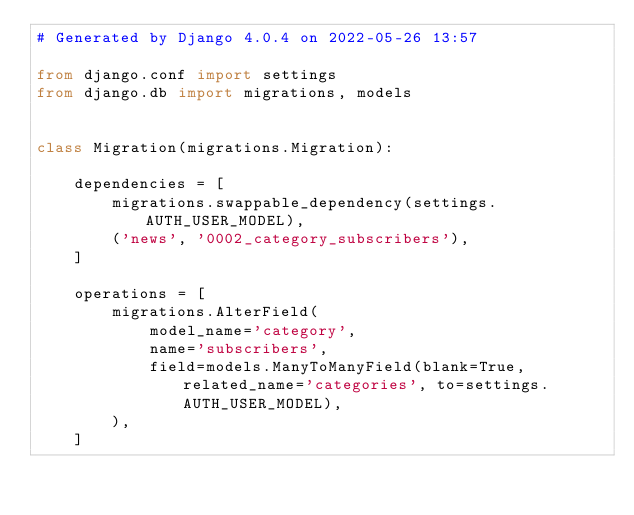Convert code to text. <code><loc_0><loc_0><loc_500><loc_500><_Python_># Generated by Django 4.0.4 on 2022-05-26 13:57

from django.conf import settings
from django.db import migrations, models


class Migration(migrations.Migration):

    dependencies = [
        migrations.swappable_dependency(settings.AUTH_USER_MODEL),
        ('news', '0002_category_subscribers'),
    ]

    operations = [
        migrations.AlterField(
            model_name='category',
            name='subscribers',
            field=models.ManyToManyField(blank=True, related_name='categories', to=settings.AUTH_USER_MODEL),
        ),
    ]
</code> 